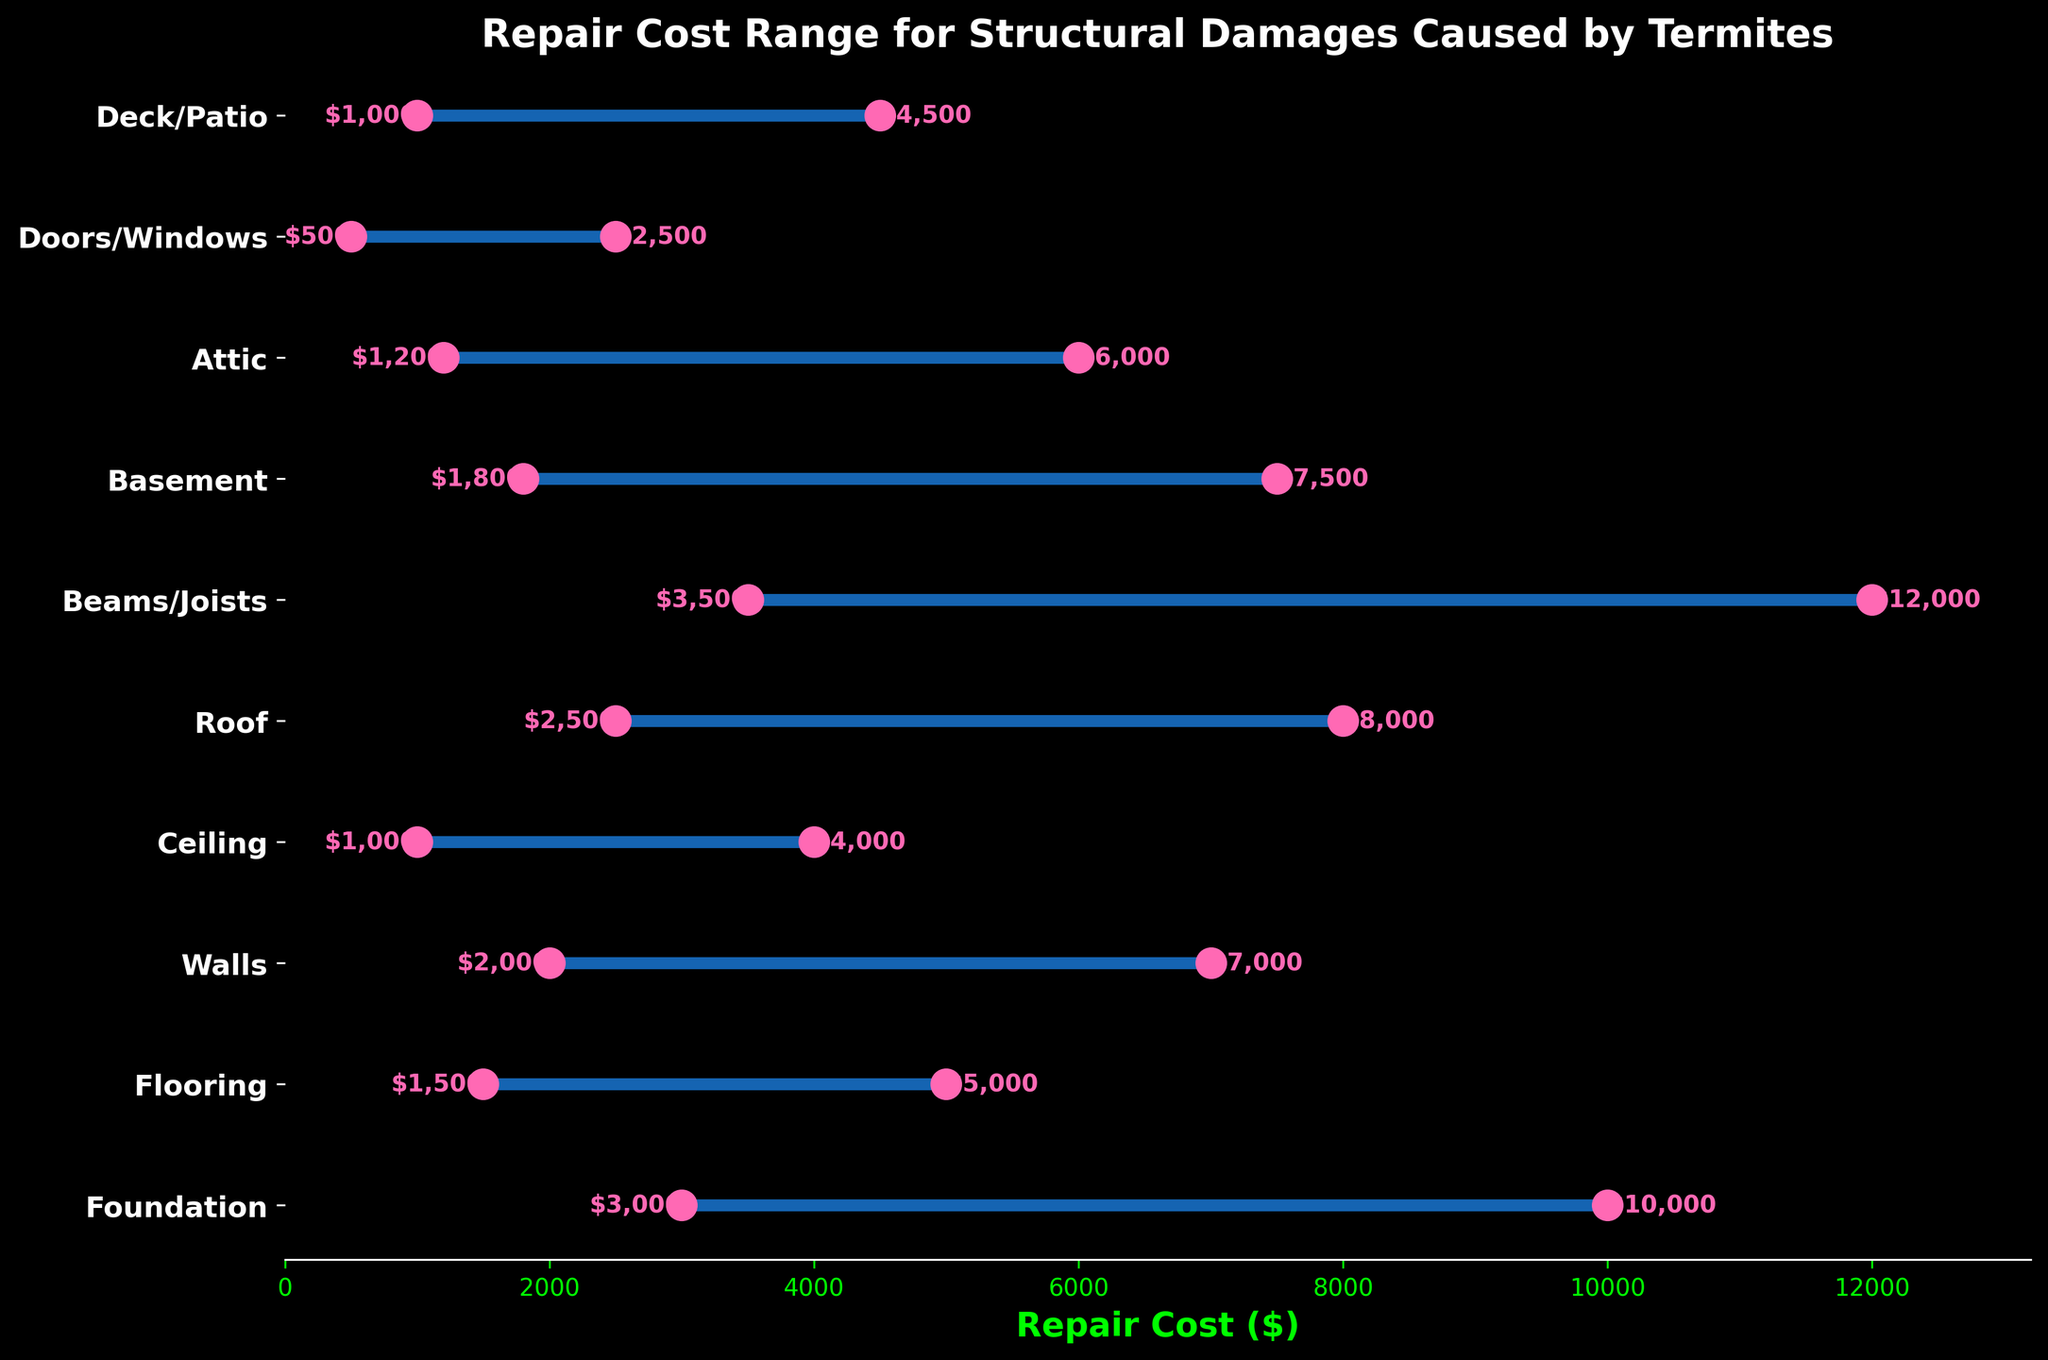What is the title of the plot? The title of the plot is located at the top and it provides a brief description of what the plot is about.
Answer: Repair Cost Range for Structural Damages Caused by Termites What is the minimum repair cost for the Foundation? The minimum repair cost for each part of the house is depicted by the leftmost pink dot on the horizontal lines. Locate the pink dot corresponding to the "Foundation" label.
Answer: $3,000 Which house part has the highest maximum repair cost? Look at the rightmost ends of all the lines, compare the values and identify which house part has the highest value.
Answer: Beams/Joists What is the range of repair costs for the Walls? Find both the minimum and maximum repair costs for the Walls, then calculate the difference between these values.
Answer: $5,000 Which house part has the lowest minimum repair cost? Look at the leftmost pink dots for all house parts and identify which has the smallest value.
Answer: Doors/Windows What is the combined maximum repair cost for the Roof and Basement? Find the maximum repair costs for both Roof and Basement then add them together. The Roof has a maximum of $8,000 and the Basement has a maximum of $7,500. Summing these values gives $8,000 + $7,500.
Answer: $15,500 Between Beams/Joists and Foundation, which one has the greater range of repair costs? Calculate the ranges for both Beams/Joists (max: $12,000 - min: $3,500 = $8,500) and Foundation (max: $10,000 - min: $3,000 = $7,000). Compare the two ranges.
Answer: Beams/Joists What is the average of the maximum repair costs shown on the plot? Add the maximum repair costs for all house parts and then divide by the number of house parts. ($10,000 + $5,000 + $7,000 + $4,000 + $8,000 + $12,000 + $7,500 + $6,000 + $2,500 + $4,500)/10
Answer: $6,750 Which house part has a minimum repair cost of $1,800? Look at the leftmost pink dots for all house parts and identify which has the value $1,800.
Answer: Basement Which house part has the closest maximum repair cost to $6,000? Look at the rightmost ends of the lines and identify which house part has the value nearest to $6,000.
Answer: Attic 